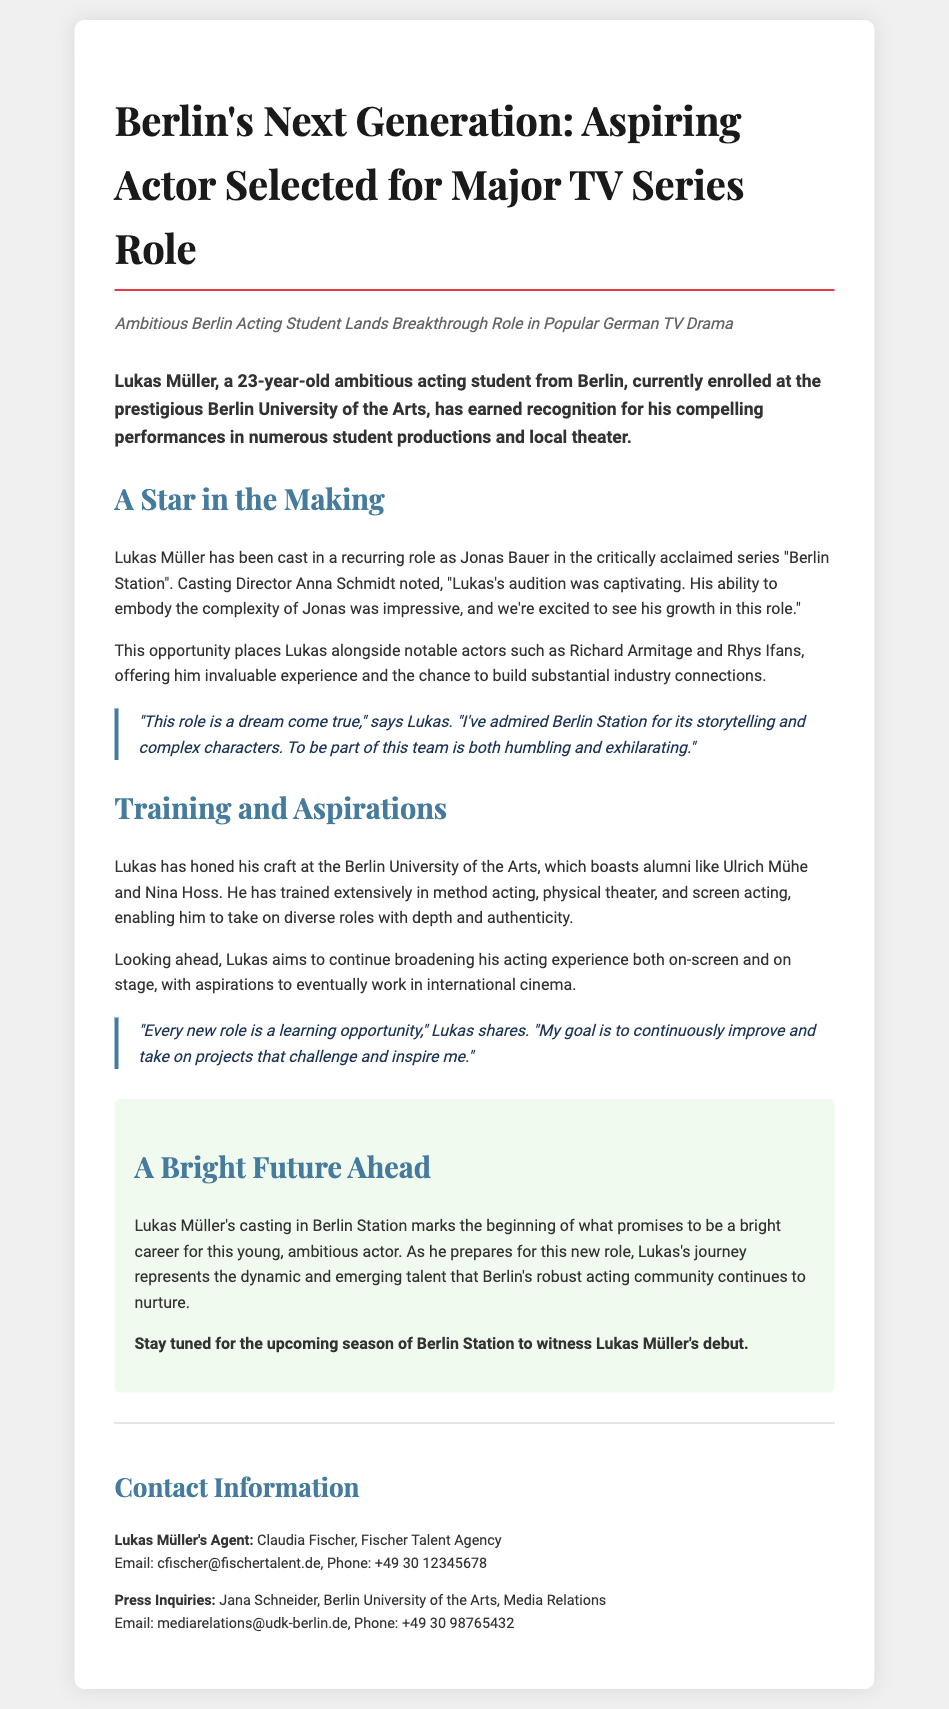What is the name of the aspiring actor? The document states the name of the aspiring actor as Lukas Müller.
Answer: Lukas Müller How old is Lukas Müller? The document mentions Lukas Müller's age as 23 years old.
Answer: 23 What role has Lukas Müller been cast in? The document specifies that Lukas Müller has been cast in the role of Jonas Bauer.
Answer: Jonas Bauer Which university is Lukas Müller attending? The document indicates that Lukas Müller is enrolled at the Berlin University of the Arts.
Answer: Berlin University of the Arts Who is the casting director mentioned in the document? The casting director’s name is Anna Schmidt, as stated in the document.
Answer: Anna Schmidt What type of acting has Lukas trained extensively in? The document lists method acting, physical theater, and screen acting as types of acting he has trained in.
Answer: Method acting, physical theater, screen acting What is Lukas's aspiration for the future? Lukas aims to work in international cinema, as expressed in the document.
Answer: Work in international cinema What is the name of the TV series Lukas will appear in? The TV series mentioned is "Berlin Station."
Answer: Berlin Station Who is Lukas Müller’s agent? The document names Claudia Fischer as Lukas Müller’s agent.
Answer: Claudia Fischer 